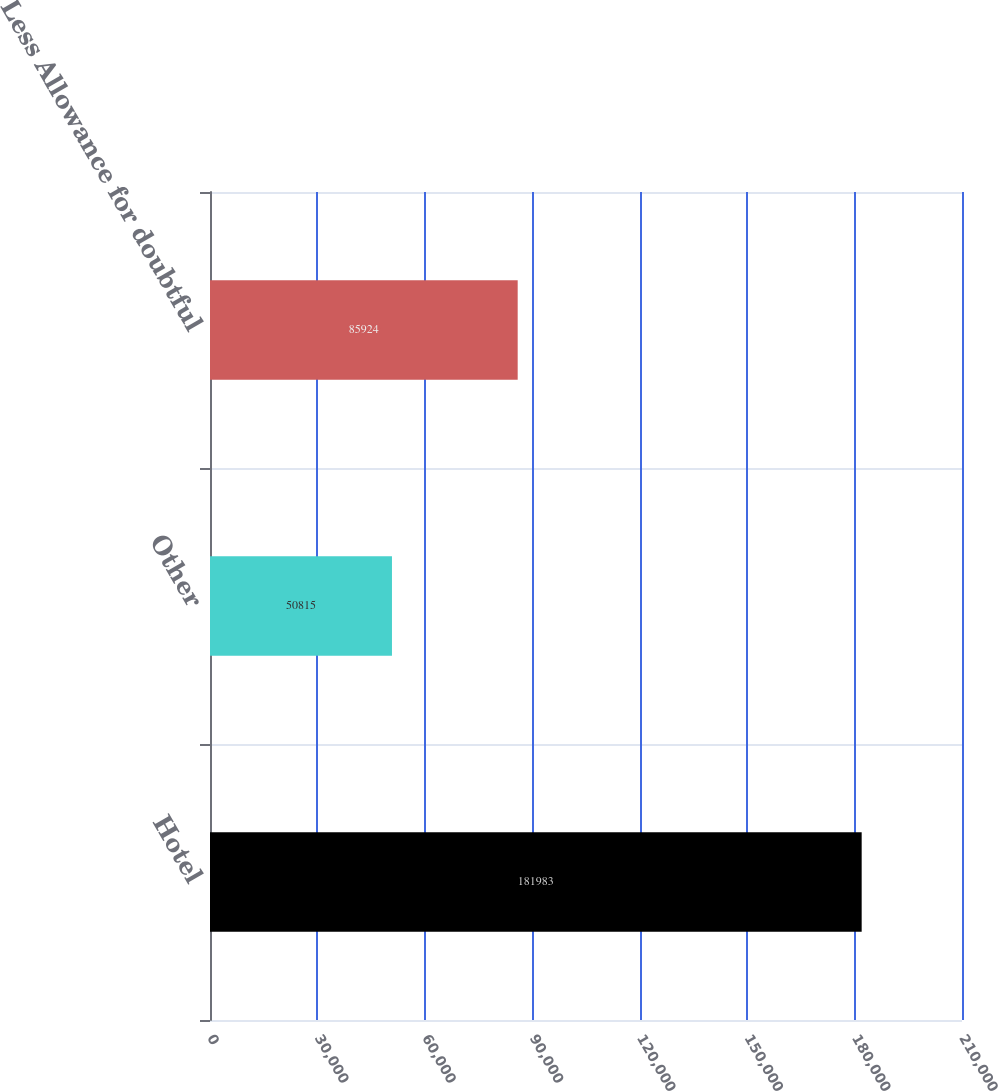Convert chart. <chart><loc_0><loc_0><loc_500><loc_500><bar_chart><fcel>Hotel<fcel>Other<fcel>Less Allowance for doubtful<nl><fcel>181983<fcel>50815<fcel>85924<nl></chart> 